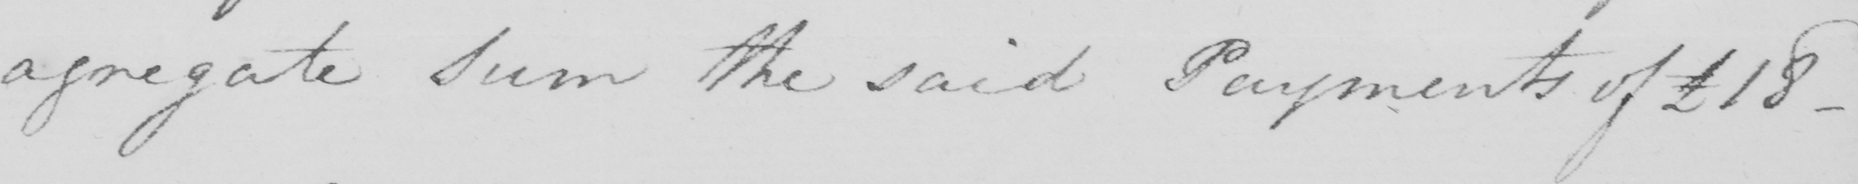Please provide the text content of this handwritten line. agregate Sum the said Payments of £18  _ 